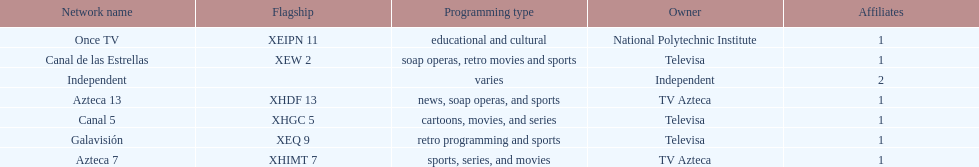What is the only network owned by national polytechnic institute? Once TV. 